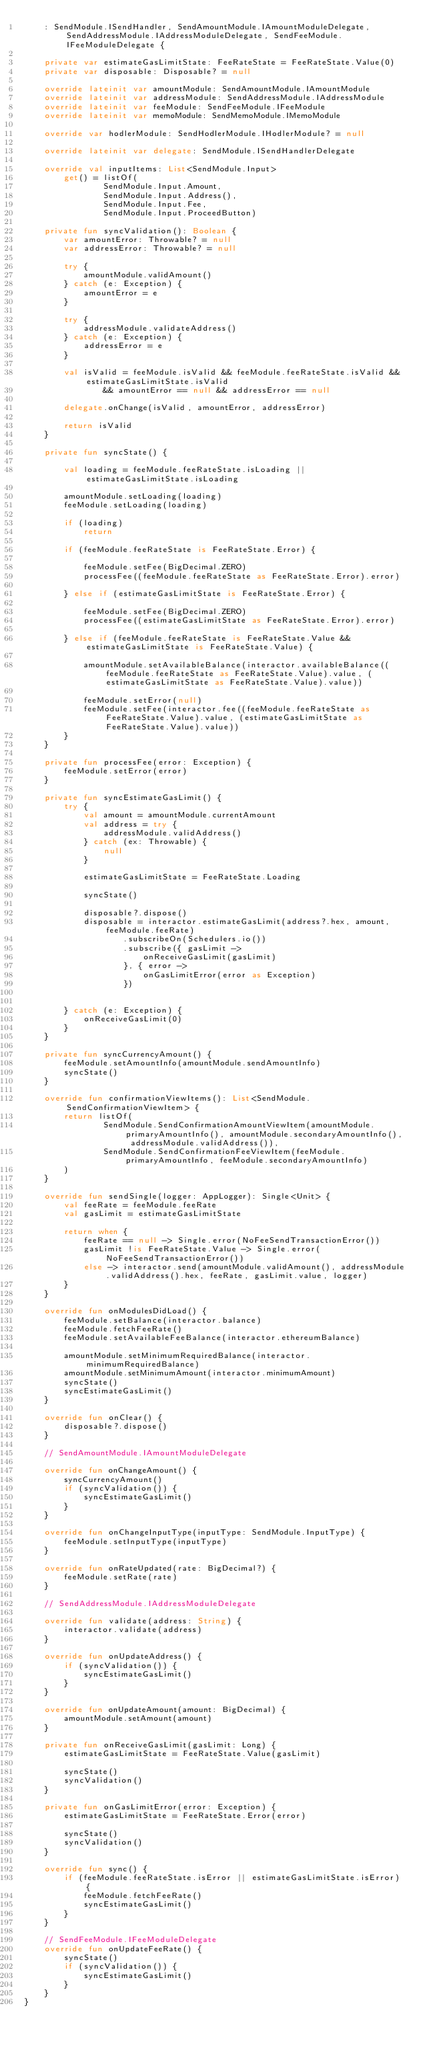Convert code to text. <code><loc_0><loc_0><loc_500><loc_500><_Kotlin_>    : SendModule.ISendHandler, SendAmountModule.IAmountModuleDelegate, SendAddressModule.IAddressModuleDelegate, SendFeeModule.IFeeModuleDelegate {

    private var estimateGasLimitState: FeeRateState = FeeRateState.Value(0)
    private var disposable: Disposable? = null

    override lateinit var amountModule: SendAmountModule.IAmountModule
    override lateinit var addressModule: SendAddressModule.IAddressModule
    override lateinit var feeModule: SendFeeModule.IFeeModule
    override lateinit var memoModule: SendMemoModule.IMemoModule

    override var hodlerModule: SendHodlerModule.IHodlerModule? = null

    override lateinit var delegate: SendModule.ISendHandlerDelegate

    override val inputItems: List<SendModule.Input>
        get() = listOf(
                SendModule.Input.Amount,
                SendModule.Input.Address(),
                SendModule.Input.Fee,
                SendModule.Input.ProceedButton)

    private fun syncValidation(): Boolean {
        var amountError: Throwable? = null
        var addressError: Throwable? = null

        try {
            amountModule.validAmount()
        } catch (e: Exception) {
            amountError = e
        }

        try {
            addressModule.validateAddress()
        } catch (e: Exception) {
            addressError = e
        }

        val isValid = feeModule.isValid && feeModule.feeRateState.isValid && estimateGasLimitState.isValid
                && amountError == null && addressError == null

        delegate.onChange(isValid, amountError, addressError)

        return isValid
    }

    private fun syncState() {

        val loading = feeModule.feeRateState.isLoading || estimateGasLimitState.isLoading

        amountModule.setLoading(loading)
        feeModule.setLoading(loading)

        if (loading)
            return

        if (feeModule.feeRateState is FeeRateState.Error) {

            feeModule.setFee(BigDecimal.ZERO)
            processFee((feeModule.feeRateState as FeeRateState.Error).error)

        } else if (estimateGasLimitState is FeeRateState.Error) {

            feeModule.setFee(BigDecimal.ZERO)
            processFee((estimateGasLimitState as FeeRateState.Error).error)

        } else if (feeModule.feeRateState is FeeRateState.Value && estimateGasLimitState is FeeRateState.Value) {

            amountModule.setAvailableBalance(interactor.availableBalance((feeModule.feeRateState as FeeRateState.Value).value, (estimateGasLimitState as FeeRateState.Value).value))

            feeModule.setError(null)
            feeModule.setFee(interactor.fee((feeModule.feeRateState as FeeRateState.Value).value, (estimateGasLimitState as FeeRateState.Value).value))
        }
    }

    private fun processFee(error: Exception) {
        feeModule.setError(error)
    }

    private fun syncEstimateGasLimit() {
        try {
            val amount = amountModule.currentAmount
            val address = try {
                addressModule.validAddress()
            } catch (ex: Throwable) {
                null
            }

            estimateGasLimitState = FeeRateState.Loading

            syncState()

            disposable?.dispose()
            disposable = interactor.estimateGasLimit(address?.hex, amount, feeModule.feeRate)
                    .subscribeOn(Schedulers.io())
                    .subscribe({ gasLimit ->
                        onReceiveGasLimit(gasLimit)
                    }, { error ->
                        onGasLimitError(error as Exception)
                    })


        } catch (e: Exception) {
            onReceiveGasLimit(0)
        }
    }

    private fun syncCurrencyAmount() {
        feeModule.setAmountInfo(amountModule.sendAmountInfo)
        syncState()
    }

    override fun confirmationViewItems(): List<SendModule.SendConfirmationViewItem> {
        return listOf(
                SendModule.SendConfirmationAmountViewItem(amountModule.primaryAmountInfo(), amountModule.secondaryAmountInfo(), addressModule.validAddress()),
                SendModule.SendConfirmationFeeViewItem(feeModule.primaryAmountInfo, feeModule.secondaryAmountInfo)
        )
    }

    override fun sendSingle(logger: AppLogger): Single<Unit> {
        val feeRate = feeModule.feeRate
        val gasLimit = estimateGasLimitState

        return when {
            feeRate == null -> Single.error(NoFeeSendTransactionError())
            gasLimit !is FeeRateState.Value -> Single.error(NoFeeSendTransactionError())
            else -> interactor.send(amountModule.validAmount(), addressModule.validAddress().hex, feeRate, gasLimit.value, logger)
        }
    }

    override fun onModulesDidLoad() {
        feeModule.setBalance(interactor.balance)
        feeModule.fetchFeeRate()
        feeModule.setAvailableFeeBalance(interactor.ethereumBalance)

        amountModule.setMinimumRequiredBalance(interactor.minimumRequiredBalance)
        amountModule.setMinimumAmount(interactor.minimumAmount)
        syncState()
        syncEstimateGasLimit()
    }

    override fun onClear() {
        disposable?.dispose()
    }

    // SendAmountModule.IAmountModuleDelegate

    override fun onChangeAmount() {
        syncCurrencyAmount()
        if (syncValidation()) {
            syncEstimateGasLimit()
        }
    }

    override fun onChangeInputType(inputType: SendModule.InputType) {
        feeModule.setInputType(inputType)
    }

    override fun onRateUpdated(rate: BigDecimal?) {
        feeModule.setRate(rate)
    }

    // SendAddressModule.IAddressModuleDelegate

    override fun validate(address: String) {
        interactor.validate(address)
    }

    override fun onUpdateAddress() {
        if (syncValidation()) {
            syncEstimateGasLimit()
        }
    }

    override fun onUpdateAmount(amount: BigDecimal) {
        amountModule.setAmount(amount)
    }

    private fun onReceiveGasLimit(gasLimit: Long) {
        estimateGasLimitState = FeeRateState.Value(gasLimit)

        syncState()
        syncValidation()
    }

    private fun onGasLimitError(error: Exception) {
        estimateGasLimitState = FeeRateState.Error(error)

        syncState()
        syncValidation()
    }

    override fun sync() {
        if (feeModule.feeRateState.isError || estimateGasLimitState.isError) {
            feeModule.fetchFeeRate()
            syncEstimateGasLimit()
        }
    }

    // SendFeeModule.IFeeModuleDelegate
    override fun onUpdateFeeRate() {
        syncState()
        if (syncValidation()) {
            syncEstimateGasLimit()
        }
    }
}
</code> 